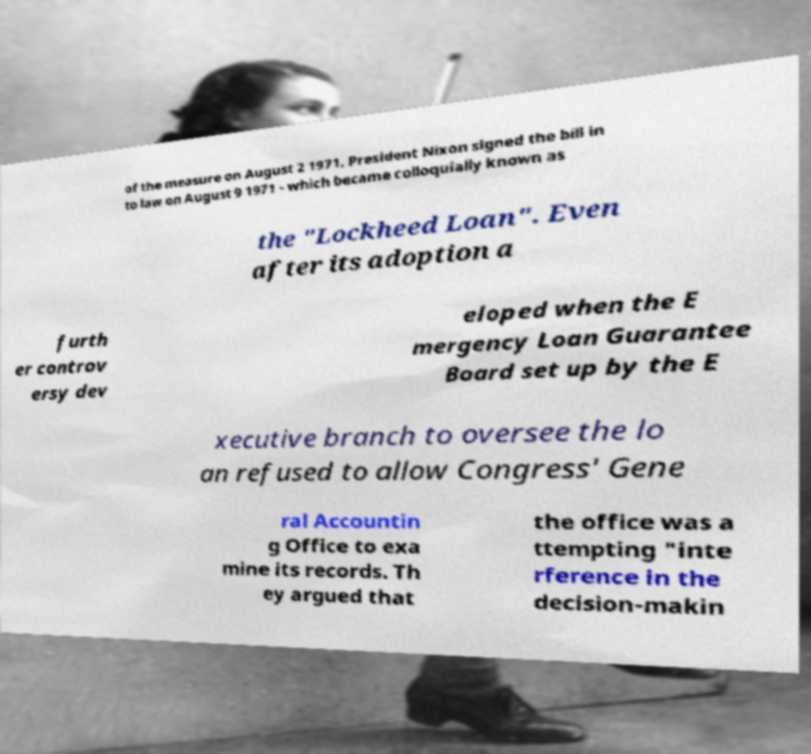Could you extract and type out the text from this image? of the measure on August 2 1971. President Nixon signed the bill in to law on August 9 1971 - which became colloquially known as the "Lockheed Loan". Even after its adoption a furth er controv ersy dev eloped when the E mergency Loan Guarantee Board set up by the E xecutive branch to oversee the lo an refused to allow Congress' Gene ral Accountin g Office to exa mine its records. Th ey argued that the office was a ttempting "inte rference in the decision-makin 